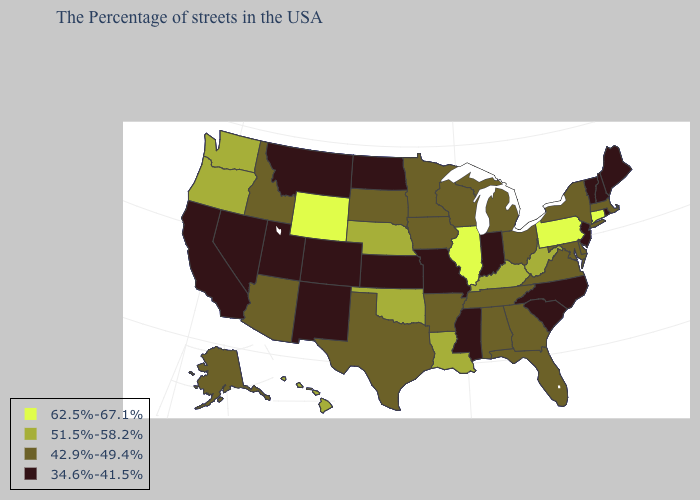What is the value of South Carolina?
Short answer required. 34.6%-41.5%. Does the map have missing data?
Quick response, please. No. What is the value of Kansas?
Write a very short answer. 34.6%-41.5%. Does the first symbol in the legend represent the smallest category?
Quick response, please. No. Which states have the highest value in the USA?
Give a very brief answer. Connecticut, Pennsylvania, Illinois, Wyoming. Does Maine have a higher value than Connecticut?
Short answer required. No. Among the states that border Kansas , which have the lowest value?
Write a very short answer. Missouri, Colorado. Does South Carolina have the lowest value in the South?
Keep it brief. Yes. What is the lowest value in the USA?
Give a very brief answer. 34.6%-41.5%. Name the states that have a value in the range 51.5%-58.2%?
Quick response, please. West Virginia, Kentucky, Louisiana, Nebraska, Oklahoma, Washington, Oregon, Hawaii. What is the highest value in the USA?
Give a very brief answer. 62.5%-67.1%. What is the lowest value in states that border Pennsylvania?
Concise answer only. 34.6%-41.5%. What is the value of West Virginia?
Quick response, please. 51.5%-58.2%. What is the highest value in the Northeast ?
Quick response, please. 62.5%-67.1%. Name the states that have a value in the range 42.9%-49.4%?
Write a very short answer. Massachusetts, New York, Delaware, Maryland, Virginia, Ohio, Florida, Georgia, Michigan, Alabama, Tennessee, Wisconsin, Arkansas, Minnesota, Iowa, Texas, South Dakota, Arizona, Idaho, Alaska. 